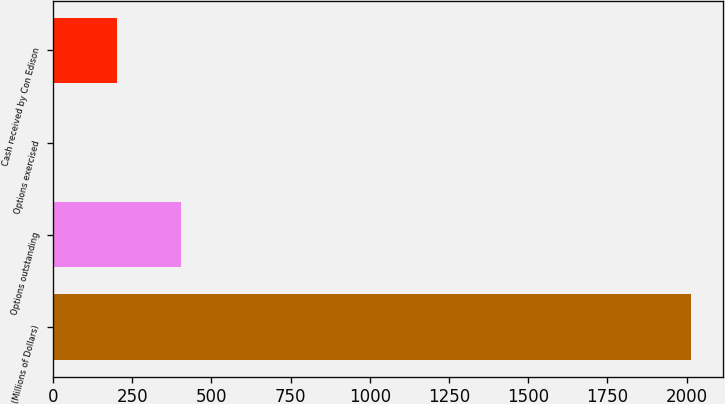Convert chart. <chart><loc_0><loc_0><loc_500><loc_500><bar_chart><fcel>(Millions of Dollars)<fcel>Options outstanding<fcel>Options exercised<fcel>Cash received by Con Edison<nl><fcel>2013<fcel>404.2<fcel>2<fcel>203.1<nl></chart> 